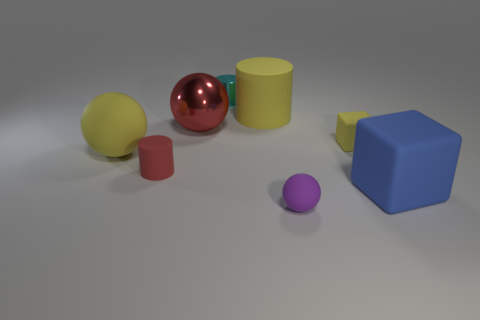Imagine if these objects were used in a game. Could you describe a simple game that involves these objects? Sure, one could envision a 3D version of a memory or matching game where players must find pairs of shapes or colors. For instance, after observing the objects for a short time, they are covered, and players take turns to recall the position of the red sphere or the blue cube. Points could be awarded for correct recalls and the player with the most points wins. 